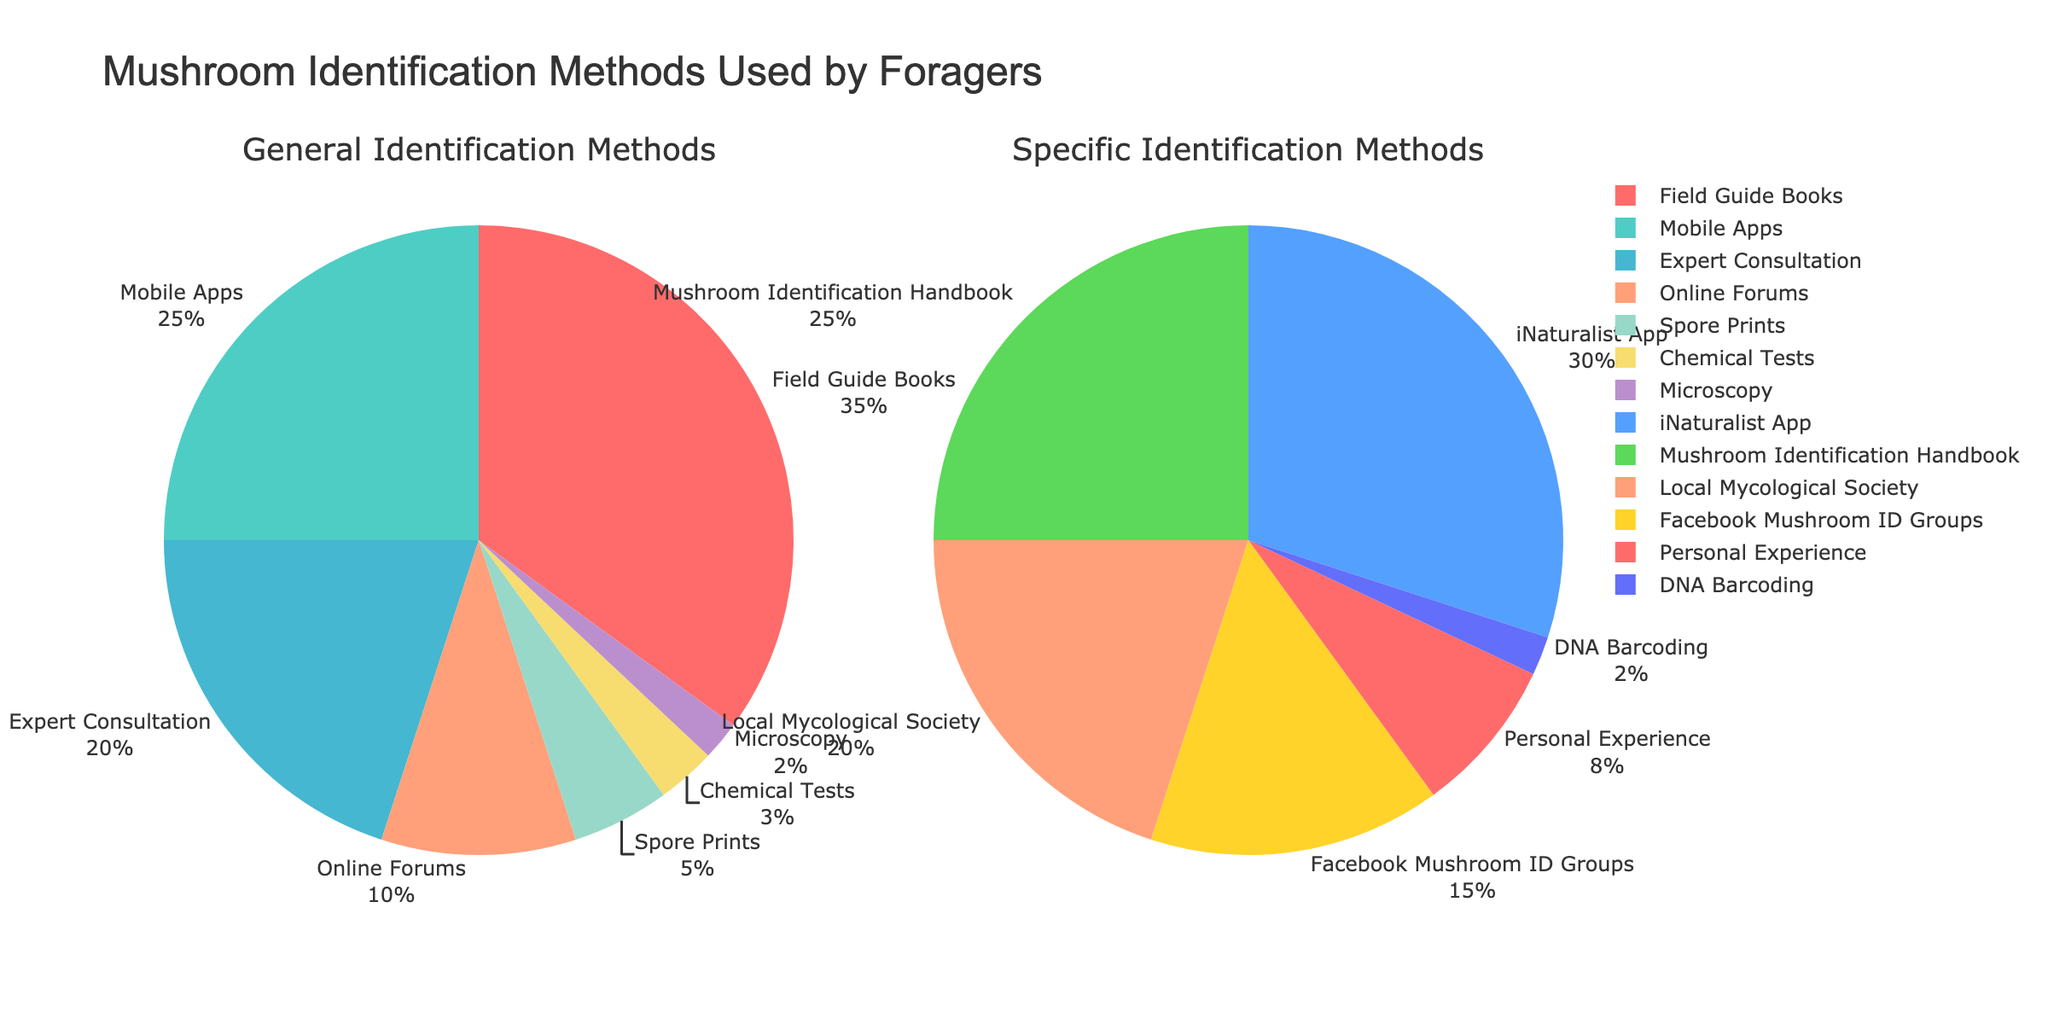What's the largest percentage of mushroom foragers using a single identification method in the 'General Identification Methods'? The pie chart for 'General Identification Methods' shows the largest section labeled 'Field Guide Books' with a percentage of 35%.
Answer: 35% What's the combined percentage of foragers using 'Online Forums' and 'Mobile Apps' in the 'General Identification Methods'? 'Online Forums' have a percentage of 10% and 'Mobile Apps' have 25%. Adding these together gives 10% + 25% = 35%.
Answer: 35% Which identification method has the smallest percentage in the 'Specific Identification Methods' pie chart? In 'Specific Identification Methods', the smallest segment is labeled 'DNA Barcoding' with a percentage of 2%.
Answer: DNA Barcoding By how much does the percentage of foragers using 'Expert Consultation' exceed those using 'Spore Prints' in 'General Identification Methods'? The percentage for 'Expert Consultation' is 20% and for 'Spore Prints' it is 5%. The difference is 20% - 5% = 15%.
Answer: 15% What's the difference in percentage between the largest segments of 'General Identification Methods' and 'Specific Identification Methods'? In 'General Identification Methods', the largest segment is 'Field Guide Books' at 35%. In 'Specific Identification Methods', the largest is 'iNaturalist App' at 30%. The difference is 35% - 30% = 5%.
Answer: 5% Which identification method is more commonly used by foragers: 'Local Mycological Society' or 'Facebook Mushroom ID Groups' in 'Specific Identification Methods'? The pie chart shows 'Local Mycological Society' at 20% and 'Facebook Mushroom ID Groups' at 15%. Therefore, 'Local Mycological Society' is more commonly used.
Answer: Local Mycological Society What is the total percentage of methods that rely on technology in 'General Identification Methods'? Methods that rely on technology in 'General Identification Methods' include 'Mobile Apps' (25%) and 'Online Forums' (10%). The total is 25% + 10% = 35%.
Answer: 35% Compare the combined percentage of the least used identification methods (below 5%) in both 'General' and 'Specific Identification Methods'. In 'General Identification Methods', the methods below 5% are 'Chemical Tests' (3%) and 'Microscopy' (2%), totaling 5%. In 'Specific Identification Methods', the only method below 5% is 'DNA Barcoding' (2%). Therefore, the combined percentage in 'General Identification Methods' is higher.
Answer: General Identification Methods Which method listed in 'Specific Identification Methods' has nearly the same percentage as 'Expert Consultation' in 'General Identification Methods'? 'Expert Consultation' in 'General Identification Methods' is 20%. In 'Specific Identification Methods', 'Local Mycological Society' also has a percentage of 20%.
Answer: Local Mycological Society 